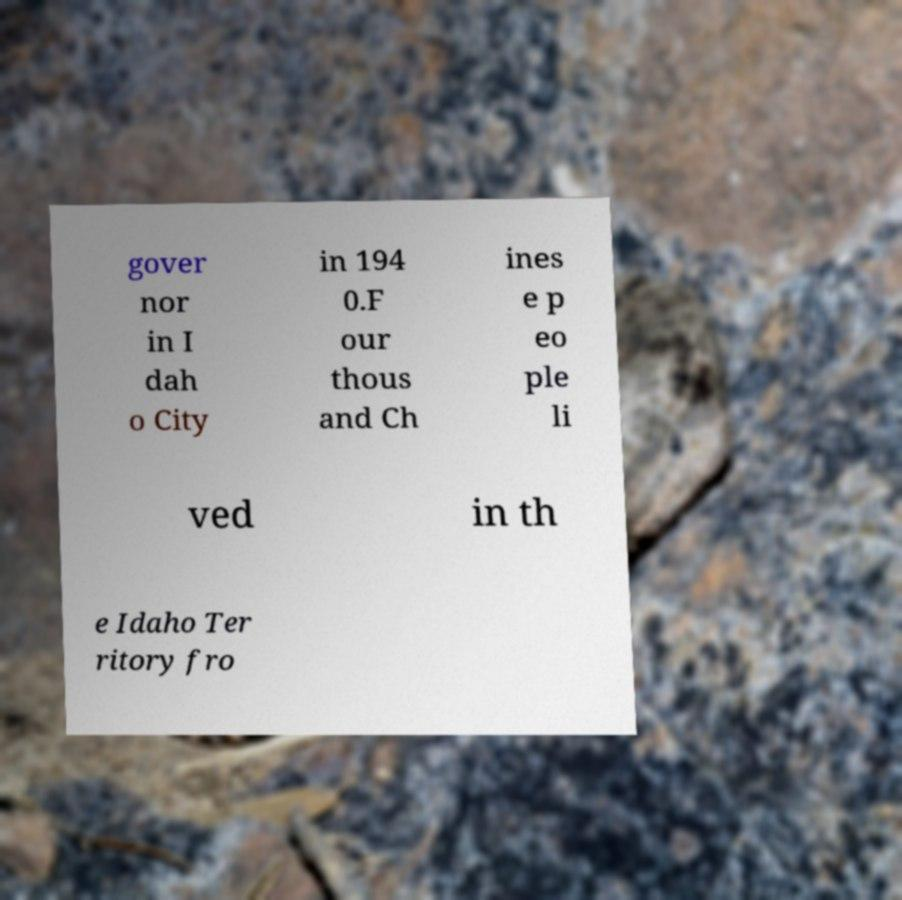Can you read and provide the text displayed in the image?This photo seems to have some interesting text. Can you extract and type it out for me? gover nor in I dah o City in 194 0.F our thous and Ch ines e p eo ple li ved in th e Idaho Ter ritory fro 